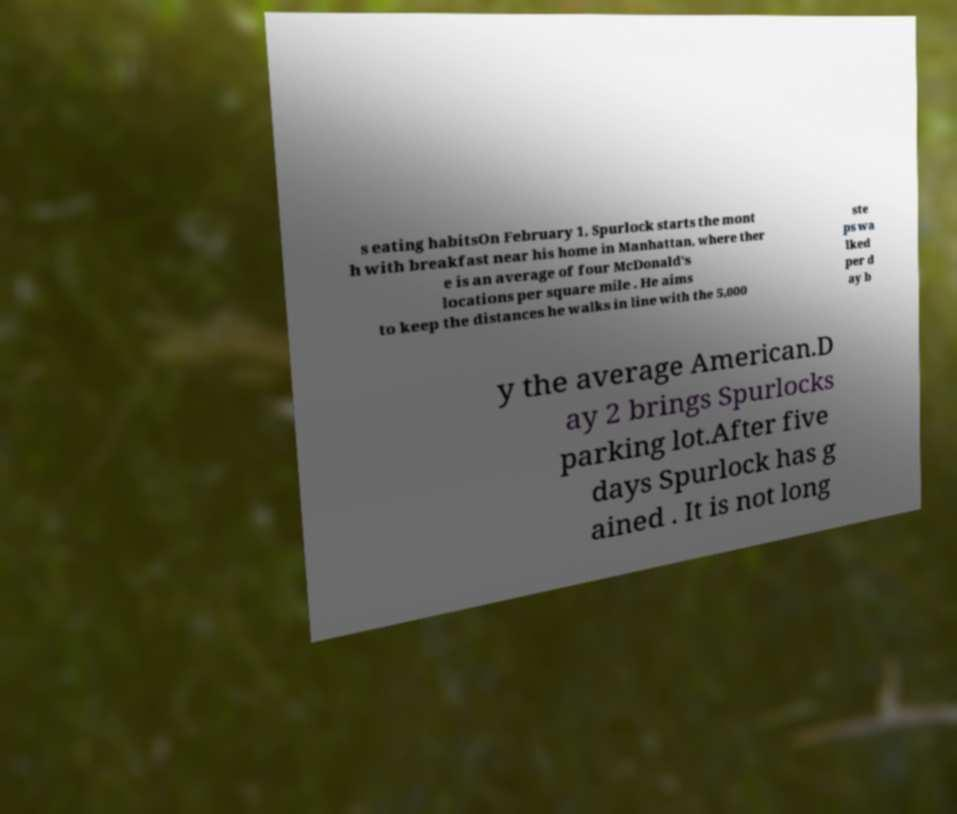There's text embedded in this image that I need extracted. Can you transcribe it verbatim? s eating habitsOn February 1, Spurlock starts the mont h with breakfast near his home in Manhattan, where ther e is an average of four McDonald's locations per square mile . He aims to keep the distances he walks in line with the 5,000 ste ps wa lked per d ay b y the average American.D ay 2 brings Spurlocks parking lot.After five days Spurlock has g ained . It is not long 